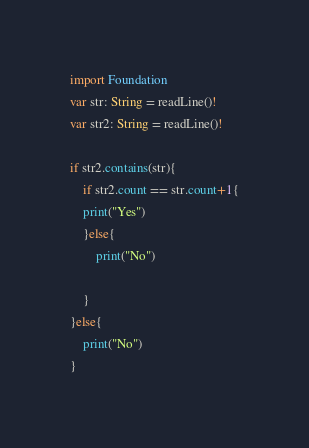<code> <loc_0><loc_0><loc_500><loc_500><_Swift_>import Foundation
var str: String = readLine()!
var str2: String = readLine()!

if str2.contains(str){
    if str2.count == str.count+1{
    print("Yes")
    }else{
        print("No")

    }
}else{
    print("No")
}</code> 